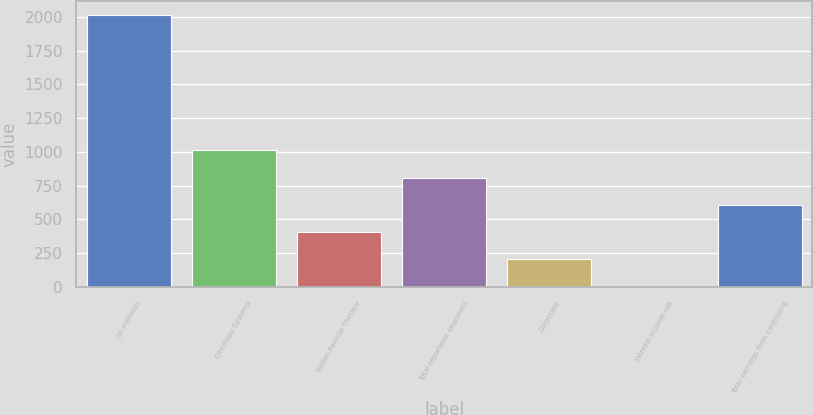Convert chart to OTSL. <chart><loc_0><loc_0><loc_500><loc_500><bar_chart><fcel>(In millions)<fcel>Oncology Systems<fcel>Varian Particle Therapy<fcel>Total reportable segments<fcel>Corporate<fcel>Interest income net<fcel>Total earnings from continuing<nl><fcel>2015<fcel>1010.3<fcel>407.48<fcel>809.36<fcel>206.54<fcel>5.6<fcel>608.42<nl></chart> 